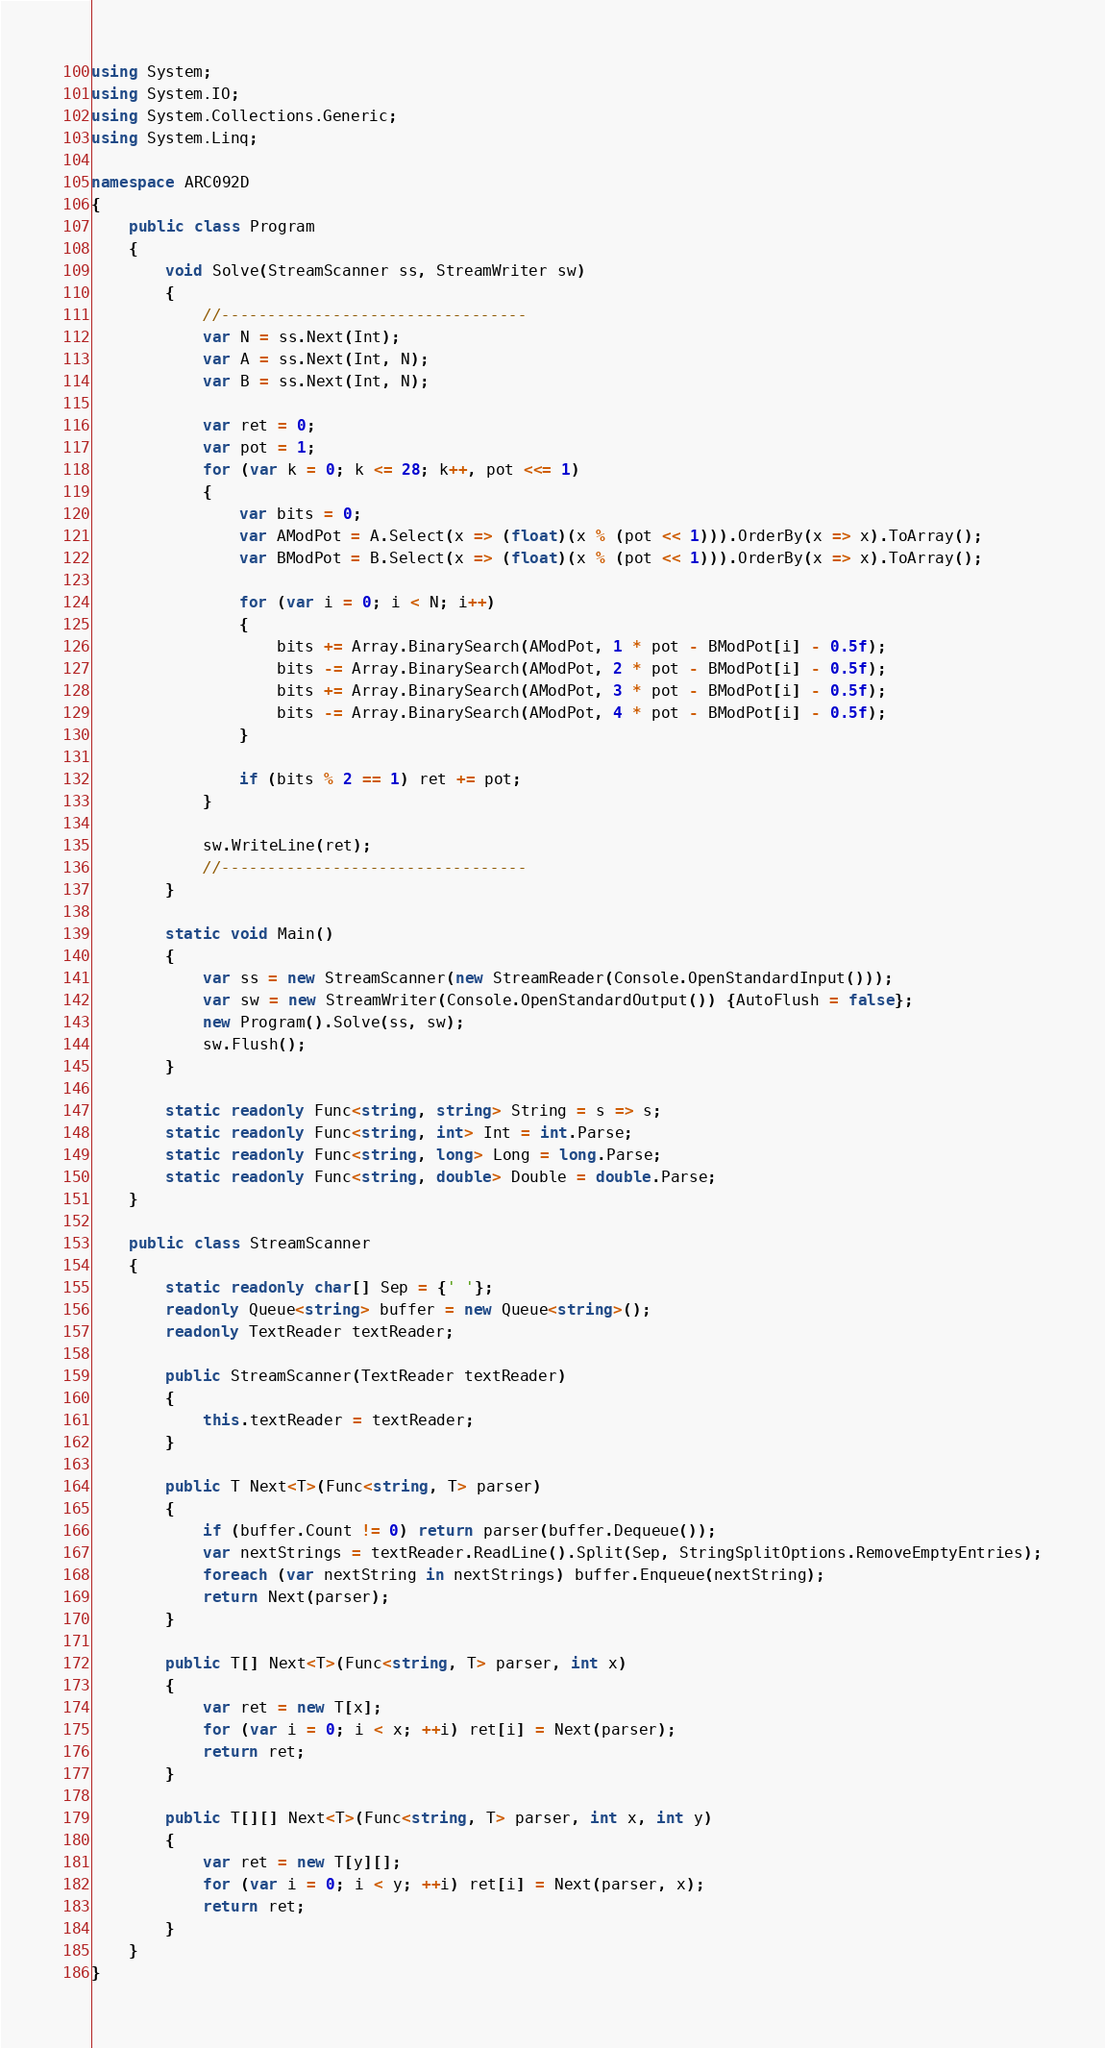<code> <loc_0><loc_0><loc_500><loc_500><_C#_>using System;
using System.IO;
using System.Collections.Generic;
using System.Linq;

namespace ARC092D
{
    public class Program
    {
        void Solve(StreamScanner ss, StreamWriter sw)
        {
            //---------------------------------
            var N = ss.Next(Int);
            var A = ss.Next(Int, N);
            var B = ss.Next(Int, N);

            var ret = 0;
            var pot = 1;
            for (var k = 0; k <= 28; k++, pot <<= 1)
            {
                var bits = 0;
                var AModPot = A.Select(x => (float)(x % (pot << 1))).OrderBy(x => x).ToArray();
                var BModPot = B.Select(x => (float)(x % (pot << 1))).OrderBy(x => x).ToArray();

                for (var i = 0; i < N; i++)
                {
                    bits += Array.BinarySearch(AModPot, 1 * pot - BModPot[i] - 0.5f);
                    bits -= Array.BinarySearch(AModPot, 2 * pot - BModPot[i] - 0.5f);
                    bits += Array.BinarySearch(AModPot, 3 * pot - BModPot[i] - 0.5f);
                    bits -= Array.BinarySearch(AModPot, 4 * pot - BModPot[i] - 0.5f);
                }

                if (bits % 2 == 1) ret += pot;
            }

            sw.WriteLine(ret);
            //---------------------------------
        }

        static void Main()
        {
            var ss = new StreamScanner(new StreamReader(Console.OpenStandardInput()));
            var sw = new StreamWriter(Console.OpenStandardOutput()) {AutoFlush = false};
            new Program().Solve(ss, sw);
            sw.Flush();
        }

        static readonly Func<string, string> String = s => s;
        static readonly Func<string, int> Int = int.Parse;
        static readonly Func<string, long> Long = long.Parse;
        static readonly Func<string, double> Double = double.Parse;
    }

    public class StreamScanner
    {
        static readonly char[] Sep = {' '};
        readonly Queue<string> buffer = new Queue<string>();
        readonly TextReader textReader;

        public StreamScanner(TextReader textReader)
        {
            this.textReader = textReader;
        }

        public T Next<T>(Func<string, T> parser)
        {
            if (buffer.Count != 0) return parser(buffer.Dequeue());
            var nextStrings = textReader.ReadLine().Split(Sep, StringSplitOptions.RemoveEmptyEntries);
            foreach (var nextString in nextStrings) buffer.Enqueue(nextString);
            return Next(parser);
        }

        public T[] Next<T>(Func<string, T> parser, int x)
        {
            var ret = new T[x];
            for (var i = 0; i < x; ++i) ret[i] = Next(parser);
            return ret;
        }

        public T[][] Next<T>(Func<string, T> parser, int x, int y)
        {
            var ret = new T[y][];
            for (var i = 0; i < y; ++i) ret[i] = Next(parser, x);
            return ret;
        }
    }
}</code> 